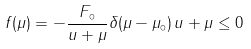Convert formula to latex. <formula><loc_0><loc_0><loc_500><loc_500>f ( \mu ) = - \frac { F _ { \circ } } { u + \mu } \delta ( \mu - \mu _ { \circ } ) \, u + \mu \leq 0</formula> 